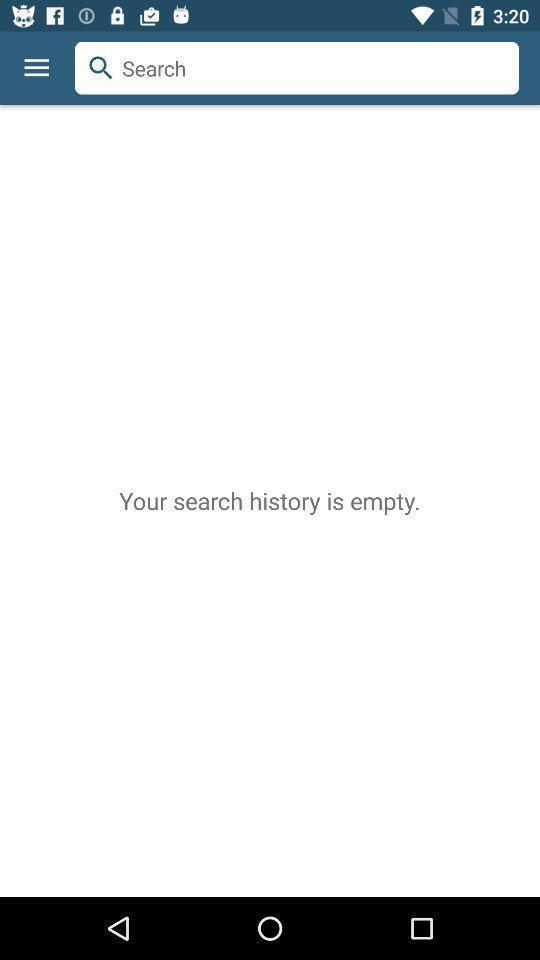Provide a description of this screenshot. Search page of history. 